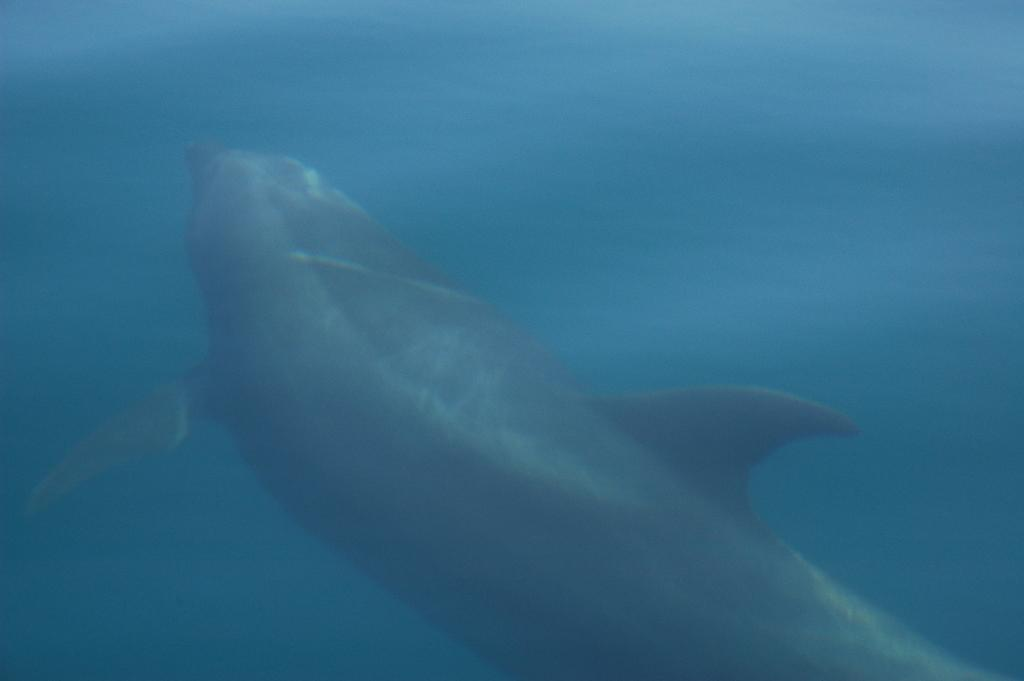What animal is in the image? There is a dolphin in the image. Where is the dolphin located? The dolphin is in the water. What page of the history book is the dolphin on in the image? There is no history book or page present in the image; it features a dolphin in the water. What railway is the dolphin traveling on in the image? There is no railway present in the image; the dolphin is in the water. 